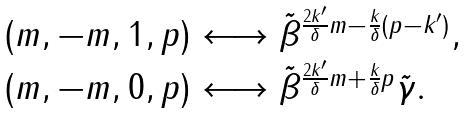<formula> <loc_0><loc_0><loc_500><loc_500>\begin{array} { l } { { ( m , - m , 1 , p ) \longleftrightarrow \tilde { \beta } ^ { \frac { 2 k ^ { \prime } } { \delta } m - \frac { k } { \delta } ( p - k ^ { \prime } ) } , } } \\ { { ( m , - m , 0 , p ) \longleftrightarrow \tilde { \beta } ^ { \frac { 2 k ^ { \prime } } { \delta } m + \frac { k } { \delta } p } \tilde { \gamma } . } } \end{array}</formula> 